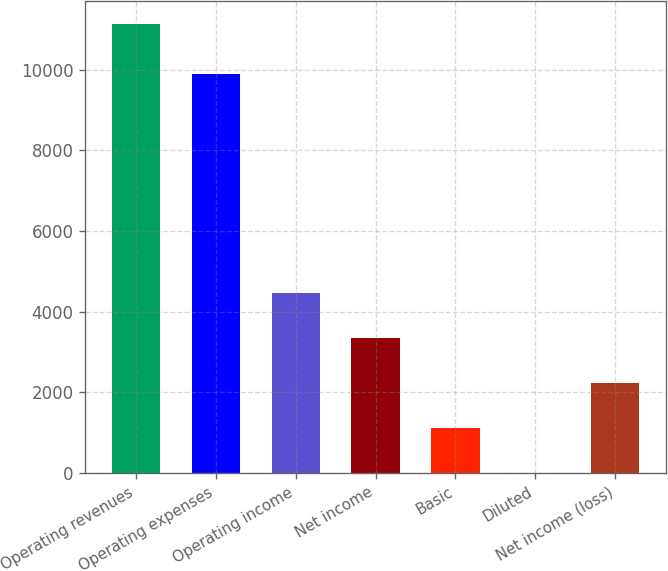Convert chart. <chart><loc_0><loc_0><loc_500><loc_500><bar_chart><fcel>Operating revenues<fcel>Operating expenses<fcel>Operating income<fcel>Net income<fcel>Basic<fcel>Diluted<fcel>Net income (loss)<nl><fcel>11139<fcel>9879<fcel>4456.36<fcel>3342.59<fcel>1115.05<fcel>1.28<fcel>2228.82<nl></chart> 